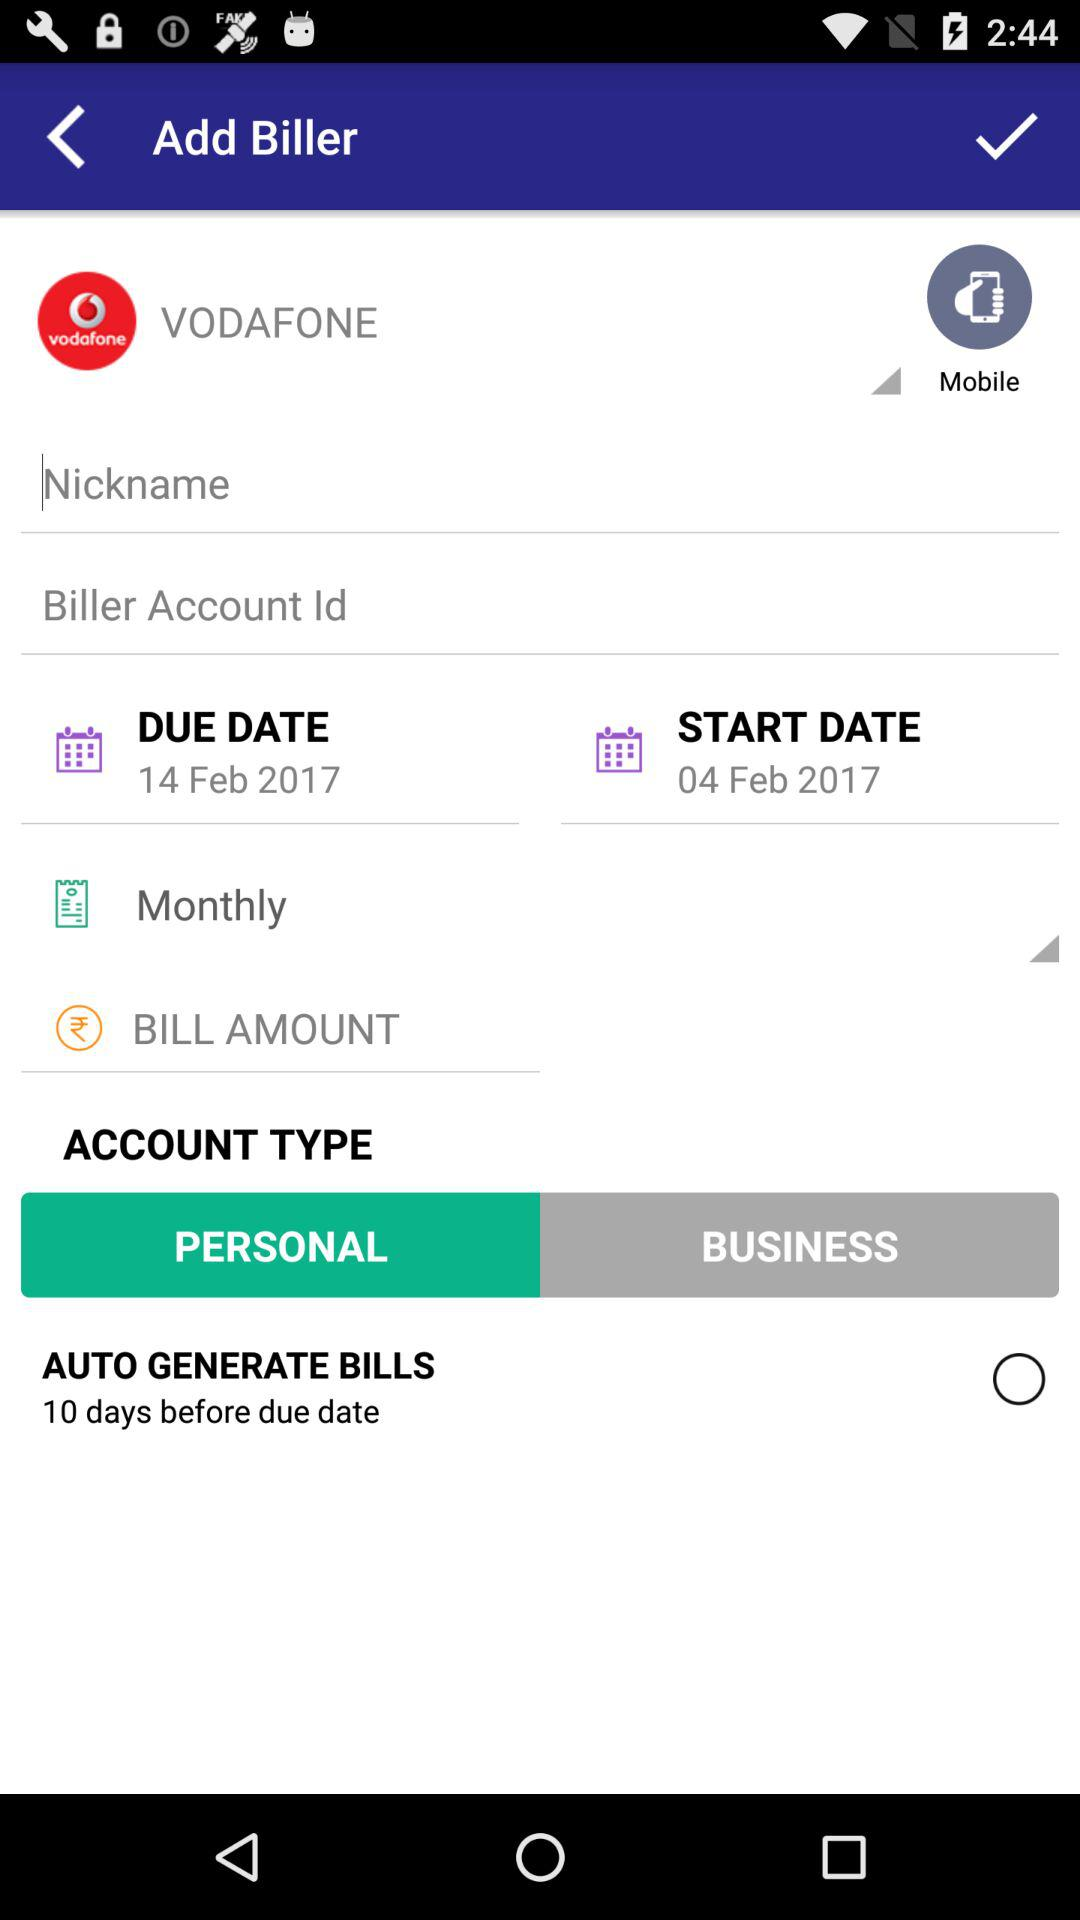How many days before the due date the bills are automatically generated? The bills are automatically generated 10 days before the due date. 